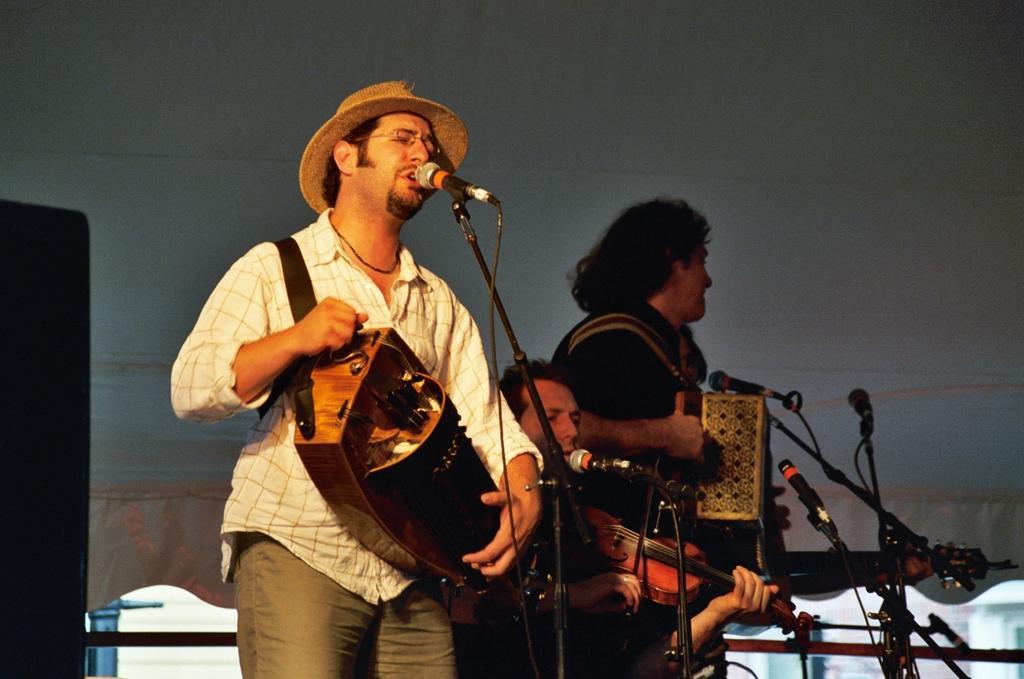How would you summarize this image in a sentence or two? This image is clicked in musical concert. There are three persons in this image. There are so many miles in the bottom side and near every person there is a mic. All of them are playing some musical instruments. 